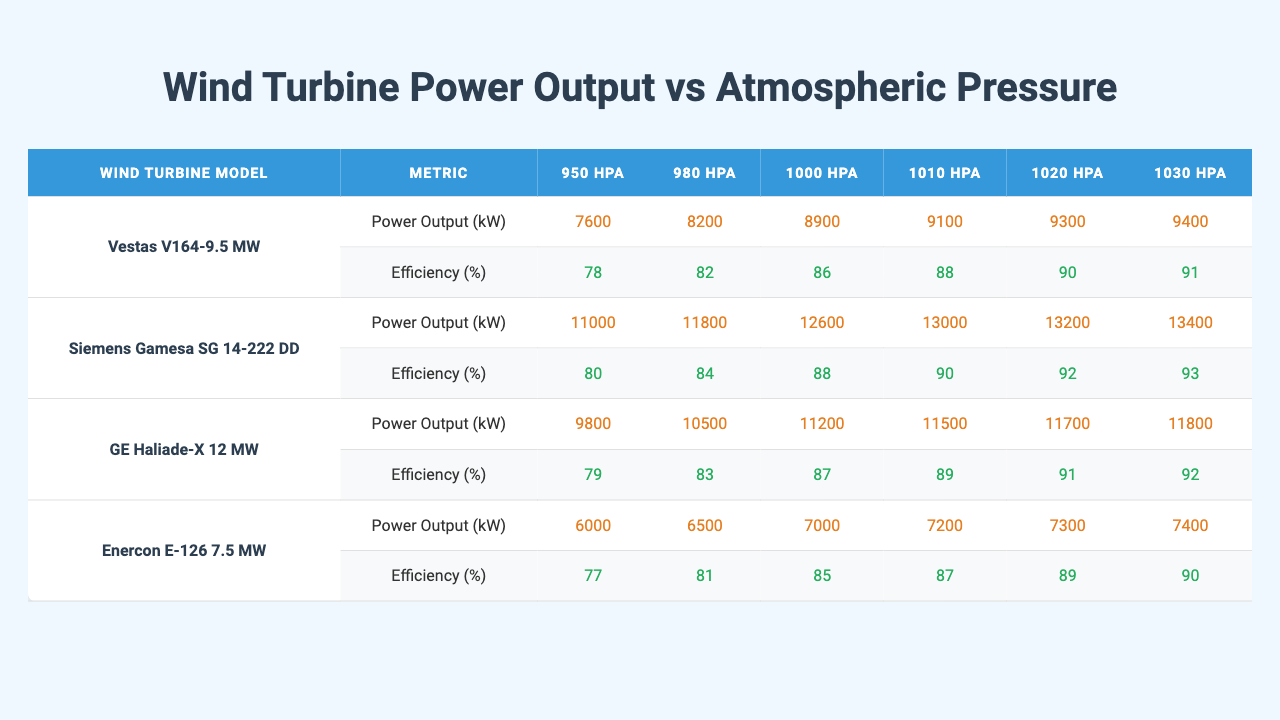What is the power output of the GE Haliade-X 12 MW at 1000 hPa? According to the table, the power output for the GE Haliade-X 12 MW at 1000 hPa is 11200 kW.
Answer: 11200 kW Which wind turbine model has the highest efficiency percentage at 1020 hPa? At 1020 hPa, the Siemens Gamesa SG 14-222 DD has the highest efficiency percentage of 92%.
Answer: 92% What is the average power output at 1010 hPa from all listed wind turbine models? The power outputs at 1010 hPa are: 9100 (Vestas V164-9.5 MW), 13000 (Siemens Gamesa SG 14-222 DD), 11500 (GE Haliade-X 12 MW), and 7200 (Enercon E-126 7.5 MW). The average is (9100 + 13000 + 11500 + 7200) / 4 = 10900 kW.
Answer: 10900 kW Is the efficiency of the Enercon E-126 7.5 MW greater than 85% at any pressure? The efficiencies for the Enercon E-126 at different pressures are 77%, 81%, 85%, 87%, 89%, and 90%. Yes, at 1010 hPa and above, the efficiency is above 85%.
Answer: Yes What is the difference in power output between the Siemens Gamesa SG 14-222 DD at 980 hPa and the Vestas V164-9.5 MW at 1020 hPa? The power output for Siemens Gamesa SG 14-222 DD at 980 hPa is 11800 kW, and for Vestas V164-9.5 MW at 1020 hPa it is 9300 kW. The difference is 11800 - 9300 = 2500 kW.
Answer: 2500 kW Which model has the overall highest power output and at which atmospheric pressure does it occur? The Siemens Gamesa SG 14-222 DD has the overall highest power output of 13400 kW, occurring at 1030 hPa.
Answer: Siemens Gamesa SG 14-222 DD at 1030 hPa At what atmospheric pressure does the Enercon E-126 7.5 MW model show its maximum efficiency? The maximum efficiency for the Enercon E-126 7.5 MW occurs at 1030 hPa with an efficiency of 90%.
Answer: 1030 hPa What is the trend of power output as atmospheric pressure increases for the Vestas V164-9.5 MW model? The power output for Vestas V164-9.5 MW increases consistently from 7600 kW at 950 hPa to 9400 kW at 1030 hPa, showing a clear upward trend with increasing atmospheric pressure.
Answer: Increasing trend Is there any wind turbine model that achieves an efficiency of 93% or higher? Yes, the Siemens Gamesa SG 14-222 DD achieves an efficiency of 93% at 1030 hPa.
Answer: Yes What atmospheric pressure corresponds to a power output of 9800 kW for the GE Haliade-X 12 MW? The power output of 9800 kW for GE Haliade-X 12 MW occurs at 950 hPa.
Answer: 950 hPa 